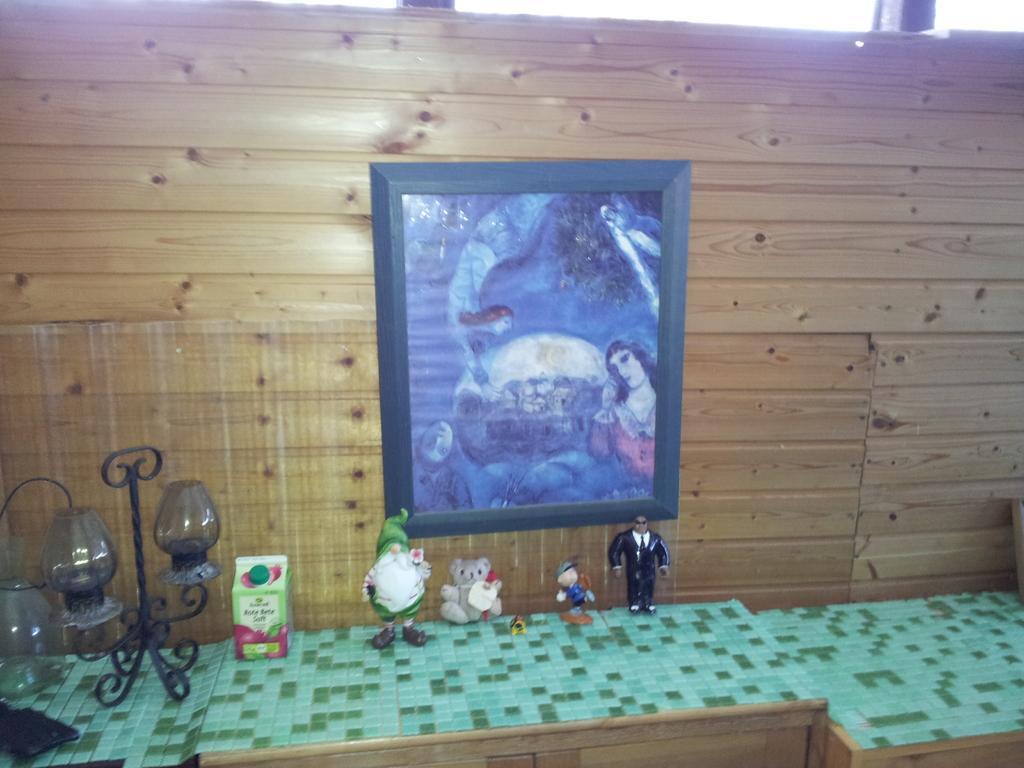Please provide a concise description of this image. there are wooden tables on which there is a green cover. upon that there are toys and a lamp. behind that there is a wooden wall on which there is a photo frame. 